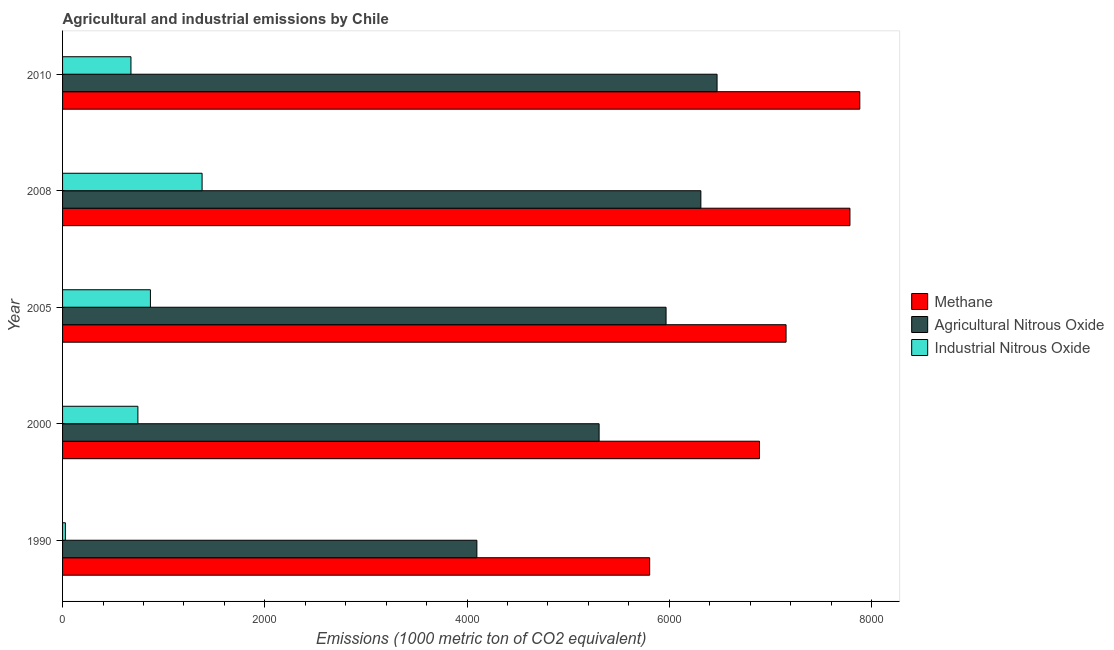What is the label of the 1st group of bars from the top?
Your response must be concise. 2010. What is the amount of methane emissions in 2005?
Your response must be concise. 7154.5. Across all years, what is the maximum amount of methane emissions?
Give a very brief answer. 7883.7. Across all years, what is the minimum amount of agricultural nitrous oxide emissions?
Your response must be concise. 4097. In which year was the amount of methane emissions maximum?
Your answer should be very brief. 2010. In which year was the amount of agricultural nitrous oxide emissions minimum?
Keep it short and to the point. 1990. What is the total amount of agricultural nitrous oxide emissions in the graph?
Offer a very short reply. 2.82e+04. What is the difference between the amount of industrial nitrous oxide emissions in 2005 and that in 2010?
Give a very brief answer. 192.5. What is the difference between the amount of agricultural nitrous oxide emissions in 1990 and the amount of methane emissions in 2005?
Give a very brief answer. -3057.5. What is the average amount of industrial nitrous oxide emissions per year?
Your answer should be compact. 739.52. In the year 2005, what is the difference between the amount of agricultural nitrous oxide emissions and amount of industrial nitrous oxide emissions?
Offer a very short reply. 5099. In how many years, is the amount of industrial nitrous oxide emissions greater than 1600 metric ton?
Your answer should be very brief. 0. What is the ratio of the amount of agricultural nitrous oxide emissions in 2000 to that in 2008?
Offer a very short reply. 0.84. Is the amount of methane emissions in 1990 less than that in 2010?
Keep it short and to the point. Yes. Is the difference between the amount of industrial nitrous oxide emissions in 2000 and 2005 greater than the difference between the amount of methane emissions in 2000 and 2005?
Your answer should be compact. Yes. What is the difference between the highest and the second highest amount of industrial nitrous oxide emissions?
Provide a short and direct response. 510.9. What is the difference between the highest and the lowest amount of industrial nitrous oxide emissions?
Ensure brevity in your answer.  1351.8. Is the sum of the amount of industrial nitrous oxide emissions in 2005 and 2010 greater than the maximum amount of methane emissions across all years?
Your answer should be compact. No. What does the 3rd bar from the top in 1990 represents?
Offer a very short reply. Methane. What does the 1st bar from the bottom in 2000 represents?
Provide a short and direct response. Methane. Is it the case that in every year, the sum of the amount of methane emissions and amount of agricultural nitrous oxide emissions is greater than the amount of industrial nitrous oxide emissions?
Your answer should be very brief. Yes. How many bars are there?
Make the answer very short. 15. How many years are there in the graph?
Ensure brevity in your answer.  5. Does the graph contain grids?
Keep it short and to the point. No. Where does the legend appear in the graph?
Keep it short and to the point. Center right. How many legend labels are there?
Your response must be concise. 3. What is the title of the graph?
Keep it short and to the point. Agricultural and industrial emissions by Chile. Does "Agriculture" appear as one of the legend labels in the graph?
Make the answer very short. No. What is the label or title of the X-axis?
Offer a very short reply. Emissions (1000 metric ton of CO2 equivalent). What is the Emissions (1000 metric ton of CO2 equivalent) in Methane in 1990?
Offer a very short reply. 5805.8. What is the Emissions (1000 metric ton of CO2 equivalent) in Agricultural Nitrous Oxide in 1990?
Your response must be concise. 4097. What is the Emissions (1000 metric ton of CO2 equivalent) of Industrial Nitrous Oxide in 1990?
Give a very brief answer. 27.9. What is the Emissions (1000 metric ton of CO2 equivalent) in Methane in 2000?
Ensure brevity in your answer.  6891.6. What is the Emissions (1000 metric ton of CO2 equivalent) of Agricultural Nitrous Oxide in 2000?
Your response must be concise. 5305.7. What is the Emissions (1000 metric ton of CO2 equivalent) of Industrial Nitrous Oxide in 2000?
Provide a succinct answer. 744.9. What is the Emissions (1000 metric ton of CO2 equivalent) of Methane in 2005?
Offer a very short reply. 7154.5. What is the Emissions (1000 metric ton of CO2 equivalent) of Agricultural Nitrous Oxide in 2005?
Provide a succinct answer. 5967.8. What is the Emissions (1000 metric ton of CO2 equivalent) in Industrial Nitrous Oxide in 2005?
Give a very brief answer. 868.8. What is the Emissions (1000 metric ton of CO2 equivalent) in Methane in 2008?
Offer a very short reply. 7786.1. What is the Emissions (1000 metric ton of CO2 equivalent) of Agricultural Nitrous Oxide in 2008?
Your answer should be compact. 6312. What is the Emissions (1000 metric ton of CO2 equivalent) in Industrial Nitrous Oxide in 2008?
Provide a succinct answer. 1379.7. What is the Emissions (1000 metric ton of CO2 equivalent) of Methane in 2010?
Your response must be concise. 7883.7. What is the Emissions (1000 metric ton of CO2 equivalent) in Agricultural Nitrous Oxide in 2010?
Offer a terse response. 6472.2. What is the Emissions (1000 metric ton of CO2 equivalent) in Industrial Nitrous Oxide in 2010?
Your answer should be very brief. 676.3. Across all years, what is the maximum Emissions (1000 metric ton of CO2 equivalent) in Methane?
Your answer should be compact. 7883.7. Across all years, what is the maximum Emissions (1000 metric ton of CO2 equivalent) in Agricultural Nitrous Oxide?
Your answer should be very brief. 6472.2. Across all years, what is the maximum Emissions (1000 metric ton of CO2 equivalent) in Industrial Nitrous Oxide?
Your answer should be compact. 1379.7. Across all years, what is the minimum Emissions (1000 metric ton of CO2 equivalent) of Methane?
Make the answer very short. 5805.8. Across all years, what is the minimum Emissions (1000 metric ton of CO2 equivalent) of Agricultural Nitrous Oxide?
Ensure brevity in your answer.  4097. Across all years, what is the minimum Emissions (1000 metric ton of CO2 equivalent) of Industrial Nitrous Oxide?
Offer a very short reply. 27.9. What is the total Emissions (1000 metric ton of CO2 equivalent) in Methane in the graph?
Your answer should be very brief. 3.55e+04. What is the total Emissions (1000 metric ton of CO2 equivalent) in Agricultural Nitrous Oxide in the graph?
Provide a succinct answer. 2.82e+04. What is the total Emissions (1000 metric ton of CO2 equivalent) of Industrial Nitrous Oxide in the graph?
Keep it short and to the point. 3697.6. What is the difference between the Emissions (1000 metric ton of CO2 equivalent) of Methane in 1990 and that in 2000?
Offer a terse response. -1085.8. What is the difference between the Emissions (1000 metric ton of CO2 equivalent) of Agricultural Nitrous Oxide in 1990 and that in 2000?
Offer a terse response. -1208.7. What is the difference between the Emissions (1000 metric ton of CO2 equivalent) of Industrial Nitrous Oxide in 1990 and that in 2000?
Keep it short and to the point. -717. What is the difference between the Emissions (1000 metric ton of CO2 equivalent) in Methane in 1990 and that in 2005?
Provide a short and direct response. -1348.7. What is the difference between the Emissions (1000 metric ton of CO2 equivalent) of Agricultural Nitrous Oxide in 1990 and that in 2005?
Your answer should be compact. -1870.8. What is the difference between the Emissions (1000 metric ton of CO2 equivalent) of Industrial Nitrous Oxide in 1990 and that in 2005?
Provide a succinct answer. -840.9. What is the difference between the Emissions (1000 metric ton of CO2 equivalent) of Methane in 1990 and that in 2008?
Offer a very short reply. -1980.3. What is the difference between the Emissions (1000 metric ton of CO2 equivalent) in Agricultural Nitrous Oxide in 1990 and that in 2008?
Keep it short and to the point. -2215. What is the difference between the Emissions (1000 metric ton of CO2 equivalent) in Industrial Nitrous Oxide in 1990 and that in 2008?
Your answer should be very brief. -1351.8. What is the difference between the Emissions (1000 metric ton of CO2 equivalent) of Methane in 1990 and that in 2010?
Give a very brief answer. -2077.9. What is the difference between the Emissions (1000 metric ton of CO2 equivalent) in Agricultural Nitrous Oxide in 1990 and that in 2010?
Your answer should be compact. -2375.2. What is the difference between the Emissions (1000 metric ton of CO2 equivalent) in Industrial Nitrous Oxide in 1990 and that in 2010?
Your answer should be very brief. -648.4. What is the difference between the Emissions (1000 metric ton of CO2 equivalent) of Methane in 2000 and that in 2005?
Your answer should be compact. -262.9. What is the difference between the Emissions (1000 metric ton of CO2 equivalent) of Agricultural Nitrous Oxide in 2000 and that in 2005?
Offer a terse response. -662.1. What is the difference between the Emissions (1000 metric ton of CO2 equivalent) of Industrial Nitrous Oxide in 2000 and that in 2005?
Your response must be concise. -123.9. What is the difference between the Emissions (1000 metric ton of CO2 equivalent) in Methane in 2000 and that in 2008?
Provide a succinct answer. -894.5. What is the difference between the Emissions (1000 metric ton of CO2 equivalent) in Agricultural Nitrous Oxide in 2000 and that in 2008?
Make the answer very short. -1006.3. What is the difference between the Emissions (1000 metric ton of CO2 equivalent) in Industrial Nitrous Oxide in 2000 and that in 2008?
Ensure brevity in your answer.  -634.8. What is the difference between the Emissions (1000 metric ton of CO2 equivalent) of Methane in 2000 and that in 2010?
Offer a terse response. -992.1. What is the difference between the Emissions (1000 metric ton of CO2 equivalent) of Agricultural Nitrous Oxide in 2000 and that in 2010?
Provide a succinct answer. -1166.5. What is the difference between the Emissions (1000 metric ton of CO2 equivalent) in Industrial Nitrous Oxide in 2000 and that in 2010?
Your answer should be compact. 68.6. What is the difference between the Emissions (1000 metric ton of CO2 equivalent) in Methane in 2005 and that in 2008?
Give a very brief answer. -631.6. What is the difference between the Emissions (1000 metric ton of CO2 equivalent) in Agricultural Nitrous Oxide in 2005 and that in 2008?
Keep it short and to the point. -344.2. What is the difference between the Emissions (1000 metric ton of CO2 equivalent) of Industrial Nitrous Oxide in 2005 and that in 2008?
Your answer should be very brief. -510.9. What is the difference between the Emissions (1000 metric ton of CO2 equivalent) of Methane in 2005 and that in 2010?
Offer a very short reply. -729.2. What is the difference between the Emissions (1000 metric ton of CO2 equivalent) of Agricultural Nitrous Oxide in 2005 and that in 2010?
Make the answer very short. -504.4. What is the difference between the Emissions (1000 metric ton of CO2 equivalent) in Industrial Nitrous Oxide in 2005 and that in 2010?
Offer a very short reply. 192.5. What is the difference between the Emissions (1000 metric ton of CO2 equivalent) in Methane in 2008 and that in 2010?
Your response must be concise. -97.6. What is the difference between the Emissions (1000 metric ton of CO2 equivalent) in Agricultural Nitrous Oxide in 2008 and that in 2010?
Your answer should be compact. -160.2. What is the difference between the Emissions (1000 metric ton of CO2 equivalent) of Industrial Nitrous Oxide in 2008 and that in 2010?
Keep it short and to the point. 703.4. What is the difference between the Emissions (1000 metric ton of CO2 equivalent) in Methane in 1990 and the Emissions (1000 metric ton of CO2 equivalent) in Agricultural Nitrous Oxide in 2000?
Provide a short and direct response. 500.1. What is the difference between the Emissions (1000 metric ton of CO2 equivalent) in Methane in 1990 and the Emissions (1000 metric ton of CO2 equivalent) in Industrial Nitrous Oxide in 2000?
Give a very brief answer. 5060.9. What is the difference between the Emissions (1000 metric ton of CO2 equivalent) of Agricultural Nitrous Oxide in 1990 and the Emissions (1000 metric ton of CO2 equivalent) of Industrial Nitrous Oxide in 2000?
Your answer should be very brief. 3352.1. What is the difference between the Emissions (1000 metric ton of CO2 equivalent) of Methane in 1990 and the Emissions (1000 metric ton of CO2 equivalent) of Agricultural Nitrous Oxide in 2005?
Provide a short and direct response. -162. What is the difference between the Emissions (1000 metric ton of CO2 equivalent) of Methane in 1990 and the Emissions (1000 metric ton of CO2 equivalent) of Industrial Nitrous Oxide in 2005?
Make the answer very short. 4937. What is the difference between the Emissions (1000 metric ton of CO2 equivalent) in Agricultural Nitrous Oxide in 1990 and the Emissions (1000 metric ton of CO2 equivalent) in Industrial Nitrous Oxide in 2005?
Ensure brevity in your answer.  3228.2. What is the difference between the Emissions (1000 metric ton of CO2 equivalent) of Methane in 1990 and the Emissions (1000 metric ton of CO2 equivalent) of Agricultural Nitrous Oxide in 2008?
Make the answer very short. -506.2. What is the difference between the Emissions (1000 metric ton of CO2 equivalent) of Methane in 1990 and the Emissions (1000 metric ton of CO2 equivalent) of Industrial Nitrous Oxide in 2008?
Keep it short and to the point. 4426.1. What is the difference between the Emissions (1000 metric ton of CO2 equivalent) in Agricultural Nitrous Oxide in 1990 and the Emissions (1000 metric ton of CO2 equivalent) in Industrial Nitrous Oxide in 2008?
Provide a succinct answer. 2717.3. What is the difference between the Emissions (1000 metric ton of CO2 equivalent) of Methane in 1990 and the Emissions (1000 metric ton of CO2 equivalent) of Agricultural Nitrous Oxide in 2010?
Provide a succinct answer. -666.4. What is the difference between the Emissions (1000 metric ton of CO2 equivalent) in Methane in 1990 and the Emissions (1000 metric ton of CO2 equivalent) in Industrial Nitrous Oxide in 2010?
Your answer should be compact. 5129.5. What is the difference between the Emissions (1000 metric ton of CO2 equivalent) in Agricultural Nitrous Oxide in 1990 and the Emissions (1000 metric ton of CO2 equivalent) in Industrial Nitrous Oxide in 2010?
Keep it short and to the point. 3420.7. What is the difference between the Emissions (1000 metric ton of CO2 equivalent) of Methane in 2000 and the Emissions (1000 metric ton of CO2 equivalent) of Agricultural Nitrous Oxide in 2005?
Keep it short and to the point. 923.8. What is the difference between the Emissions (1000 metric ton of CO2 equivalent) of Methane in 2000 and the Emissions (1000 metric ton of CO2 equivalent) of Industrial Nitrous Oxide in 2005?
Keep it short and to the point. 6022.8. What is the difference between the Emissions (1000 metric ton of CO2 equivalent) in Agricultural Nitrous Oxide in 2000 and the Emissions (1000 metric ton of CO2 equivalent) in Industrial Nitrous Oxide in 2005?
Provide a succinct answer. 4436.9. What is the difference between the Emissions (1000 metric ton of CO2 equivalent) in Methane in 2000 and the Emissions (1000 metric ton of CO2 equivalent) in Agricultural Nitrous Oxide in 2008?
Provide a succinct answer. 579.6. What is the difference between the Emissions (1000 metric ton of CO2 equivalent) of Methane in 2000 and the Emissions (1000 metric ton of CO2 equivalent) of Industrial Nitrous Oxide in 2008?
Ensure brevity in your answer.  5511.9. What is the difference between the Emissions (1000 metric ton of CO2 equivalent) in Agricultural Nitrous Oxide in 2000 and the Emissions (1000 metric ton of CO2 equivalent) in Industrial Nitrous Oxide in 2008?
Provide a succinct answer. 3926. What is the difference between the Emissions (1000 metric ton of CO2 equivalent) in Methane in 2000 and the Emissions (1000 metric ton of CO2 equivalent) in Agricultural Nitrous Oxide in 2010?
Give a very brief answer. 419.4. What is the difference between the Emissions (1000 metric ton of CO2 equivalent) in Methane in 2000 and the Emissions (1000 metric ton of CO2 equivalent) in Industrial Nitrous Oxide in 2010?
Provide a succinct answer. 6215.3. What is the difference between the Emissions (1000 metric ton of CO2 equivalent) in Agricultural Nitrous Oxide in 2000 and the Emissions (1000 metric ton of CO2 equivalent) in Industrial Nitrous Oxide in 2010?
Keep it short and to the point. 4629.4. What is the difference between the Emissions (1000 metric ton of CO2 equivalent) of Methane in 2005 and the Emissions (1000 metric ton of CO2 equivalent) of Agricultural Nitrous Oxide in 2008?
Offer a terse response. 842.5. What is the difference between the Emissions (1000 metric ton of CO2 equivalent) of Methane in 2005 and the Emissions (1000 metric ton of CO2 equivalent) of Industrial Nitrous Oxide in 2008?
Your answer should be very brief. 5774.8. What is the difference between the Emissions (1000 metric ton of CO2 equivalent) in Agricultural Nitrous Oxide in 2005 and the Emissions (1000 metric ton of CO2 equivalent) in Industrial Nitrous Oxide in 2008?
Make the answer very short. 4588.1. What is the difference between the Emissions (1000 metric ton of CO2 equivalent) of Methane in 2005 and the Emissions (1000 metric ton of CO2 equivalent) of Agricultural Nitrous Oxide in 2010?
Keep it short and to the point. 682.3. What is the difference between the Emissions (1000 metric ton of CO2 equivalent) of Methane in 2005 and the Emissions (1000 metric ton of CO2 equivalent) of Industrial Nitrous Oxide in 2010?
Keep it short and to the point. 6478.2. What is the difference between the Emissions (1000 metric ton of CO2 equivalent) of Agricultural Nitrous Oxide in 2005 and the Emissions (1000 metric ton of CO2 equivalent) of Industrial Nitrous Oxide in 2010?
Provide a short and direct response. 5291.5. What is the difference between the Emissions (1000 metric ton of CO2 equivalent) of Methane in 2008 and the Emissions (1000 metric ton of CO2 equivalent) of Agricultural Nitrous Oxide in 2010?
Ensure brevity in your answer.  1313.9. What is the difference between the Emissions (1000 metric ton of CO2 equivalent) in Methane in 2008 and the Emissions (1000 metric ton of CO2 equivalent) in Industrial Nitrous Oxide in 2010?
Offer a terse response. 7109.8. What is the difference between the Emissions (1000 metric ton of CO2 equivalent) of Agricultural Nitrous Oxide in 2008 and the Emissions (1000 metric ton of CO2 equivalent) of Industrial Nitrous Oxide in 2010?
Give a very brief answer. 5635.7. What is the average Emissions (1000 metric ton of CO2 equivalent) in Methane per year?
Keep it short and to the point. 7104.34. What is the average Emissions (1000 metric ton of CO2 equivalent) of Agricultural Nitrous Oxide per year?
Offer a terse response. 5630.94. What is the average Emissions (1000 metric ton of CO2 equivalent) of Industrial Nitrous Oxide per year?
Give a very brief answer. 739.52. In the year 1990, what is the difference between the Emissions (1000 metric ton of CO2 equivalent) of Methane and Emissions (1000 metric ton of CO2 equivalent) of Agricultural Nitrous Oxide?
Your answer should be very brief. 1708.8. In the year 1990, what is the difference between the Emissions (1000 metric ton of CO2 equivalent) in Methane and Emissions (1000 metric ton of CO2 equivalent) in Industrial Nitrous Oxide?
Your answer should be compact. 5777.9. In the year 1990, what is the difference between the Emissions (1000 metric ton of CO2 equivalent) in Agricultural Nitrous Oxide and Emissions (1000 metric ton of CO2 equivalent) in Industrial Nitrous Oxide?
Offer a very short reply. 4069.1. In the year 2000, what is the difference between the Emissions (1000 metric ton of CO2 equivalent) in Methane and Emissions (1000 metric ton of CO2 equivalent) in Agricultural Nitrous Oxide?
Your response must be concise. 1585.9. In the year 2000, what is the difference between the Emissions (1000 metric ton of CO2 equivalent) of Methane and Emissions (1000 metric ton of CO2 equivalent) of Industrial Nitrous Oxide?
Offer a very short reply. 6146.7. In the year 2000, what is the difference between the Emissions (1000 metric ton of CO2 equivalent) of Agricultural Nitrous Oxide and Emissions (1000 metric ton of CO2 equivalent) of Industrial Nitrous Oxide?
Provide a succinct answer. 4560.8. In the year 2005, what is the difference between the Emissions (1000 metric ton of CO2 equivalent) in Methane and Emissions (1000 metric ton of CO2 equivalent) in Agricultural Nitrous Oxide?
Your answer should be compact. 1186.7. In the year 2005, what is the difference between the Emissions (1000 metric ton of CO2 equivalent) in Methane and Emissions (1000 metric ton of CO2 equivalent) in Industrial Nitrous Oxide?
Make the answer very short. 6285.7. In the year 2005, what is the difference between the Emissions (1000 metric ton of CO2 equivalent) in Agricultural Nitrous Oxide and Emissions (1000 metric ton of CO2 equivalent) in Industrial Nitrous Oxide?
Provide a succinct answer. 5099. In the year 2008, what is the difference between the Emissions (1000 metric ton of CO2 equivalent) of Methane and Emissions (1000 metric ton of CO2 equivalent) of Agricultural Nitrous Oxide?
Keep it short and to the point. 1474.1. In the year 2008, what is the difference between the Emissions (1000 metric ton of CO2 equivalent) in Methane and Emissions (1000 metric ton of CO2 equivalent) in Industrial Nitrous Oxide?
Offer a very short reply. 6406.4. In the year 2008, what is the difference between the Emissions (1000 metric ton of CO2 equivalent) in Agricultural Nitrous Oxide and Emissions (1000 metric ton of CO2 equivalent) in Industrial Nitrous Oxide?
Make the answer very short. 4932.3. In the year 2010, what is the difference between the Emissions (1000 metric ton of CO2 equivalent) in Methane and Emissions (1000 metric ton of CO2 equivalent) in Agricultural Nitrous Oxide?
Provide a succinct answer. 1411.5. In the year 2010, what is the difference between the Emissions (1000 metric ton of CO2 equivalent) in Methane and Emissions (1000 metric ton of CO2 equivalent) in Industrial Nitrous Oxide?
Your answer should be compact. 7207.4. In the year 2010, what is the difference between the Emissions (1000 metric ton of CO2 equivalent) in Agricultural Nitrous Oxide and Emissions (1000 metric ton of CO2 equivalent) in Industrial Nitrous Oxide?
Keep it short and to the point. 5795.9. What is the ratio of the Emissions (1000 metric ton of CO2 equivalent) of Methane in 1990 to that in 2000?
Provide a succinct answer. 0.84. What is the ratio of the Emissions (1000 metric ton of CO2 equivalent) in Agricultural Nitrous Oxide in 1990 to that in 2000?
Your answer should be very brief. 0.77. What is the ratio of the Emissions (1000 metric ton of CO2 equivalent) in Industrial Nitrous Oxide in 1990 to that in 2000?
Make the answer very short. 0.04. What is the ratio of the Emissions (1000 metric ton of CO2 equivalent) of Methane in 1990 to that in 2005?
Your response must be concise. 0.81. What is the ratio of the Emissions (1000 metric ton of CO2 equivalent) in Agricultural Nitrous Oxide in 1990 to that in 2005?
Offer a terse response. 0.69. What is the ratio of the Emissions (1000 metric ton of CO2 equivalent) of Industrial Nitrous Oxide in 1990 to that in 2005?
Make the answer very short. 0.03. What is the ratio of the Emissions (1000 metric ton of CO2 equivalent) of Methane in 1990 to that in 2008?
Give a very brief answer. 0.75. What is the ratio of the Emissions (1000 metric ton of CO2 equivalent) of Agricultural Nitrous Oxide in 1990 to that in 2008?
Give a very brief answer. 0.65. What is the ratio of the Emissions (1000 metric ton of CO2 equivalent) in Industrial Nitrous Oxide in 1990 to that in 2008?
Offer a terse response. 0.02. What is the ratio of the Emissions (1000 metric ton of CO2 equivalent) of Methane in 1990 to that in 2010?
Your answer should be compact. 0.74. What is the ratio of the Emissions (1000 metric ton of CO2 equivalent) of Agricultural Nitrous Oxide in 1990 to that in 2010?
Offer a very short reply. 0.63. What is the ratio of the Emissions (1000 metric ton of CO2 equivalent) in Industrial Nitrous Oxide in 1990 to that in 2010?
Your answer should be very brief. 0.04. What is the ratio of the Emissions (1000 metric ton of CO2 equivalent) of Methane in 2000 to that in 2005?
Your answer should be very brief. 0.96. What is the ratio of the Emissions (1000 metric ton of CO2 equivalent) in Agricultural Nitrous Oxide in 2000 to that in 2005?
Ensure brevity in your answer.  0.89. What is the ratio of the Emissions (1000 metric ton of CO2 equivalent) of Industrial Nitrous Oxide in 2000 to that in 2005?
Offer a terse response. 0.86. What is the ratio of the Emissions (1000 metric ton of CO2 equivalent) in Methane in 2000 to that in 2008?
Your answer should be very brief. 0.89. What is the ratio of the Emissions (1000 metric ton of CO2 equivalent) of Agricultural Nitrous Oxide in 2000 to that in 2008?
Offer a terse response. 0.84. What is the ratio of the Emissions (1000 metric ton of CO2 equivalent) of Industrial Nitrous Oxide in 2000 to that in 2008?
Keep it short and to the point. 0.54. What is the ratio of the Emissions (1000 metric ton of CO2 equivalent) in Methane in 2000 to that in 2010?
Give a very brief answer. 0.87. What is the ratio of the Emissions (1000 metric ton of CO2 equivalent) in Agricultural Nitrous Oxide in 2000 to that in 2010?
Ensure brevity in your answer.  0.82. What is the ratio of the Emissions (1000 metric ton of CO2 equivalent) in Industrial Nitrous Oxide in 2000 to that in 2010?
Ensure brevity in your answer.  1.1. What is the ratio of the Emissions (1000 metric ton of CO2 equivalent) in Methane in 2005 to that in 2008?
Your response must be concise. 0.92. What is the ratio of the Emissions (1000 metric ton of CO2 equivalent) in Agricultural Nitrous Oxide in 2005 to that in 2008?
Provide a short and direct response. 0.95. What is the ratio of the Emissions (1000 metric ton of CO2 equivalent) of Industrial Nitrous Oxide in 2005 to that in 2008?
Ensure brevity in your answer.  0.63. What is the ratio of the Emissions (1000 metric ton of CO2 equivalent) in Methane in 2005 to that in 2010?
Your answer should be very brief. 0.91. What is the ratio of the Emissions (1000 metric ton of CO2 equivalent) of Agricultural Nitrous Oxide in 2005 to that in 2010?
Your answer should be very brief. 0.92. What is the ratio of the Emissions (1000 metric ton of CO2 equivalent) in Industrial Nitrous Oxide in 2005 to that in 2010?
Offer a terse response. 1.28. What is the ratio of the Emissions (1000 metric ton of CO2 equivalent) of Methane in 2008 to that in 2010?
Your response must be concise. 0.99. What is the ratio of the Emissions (1000 metric ton of CO2 equivalent) of Agricultural Nitrous Oxide in 2008 to that in 2010?
Offer a very short reply. 0.98. What is the ratio of the Emissions (1000 metric ton of CO2 equivalent) in Industrial Nitrous Oxide in 2008 to that in 2010?
Keep it short and to the point. 2.04. What is the difference between the highest and the second highest Emissions (1000 metric ton of CO2 equivalent) of Methane?
Make the answer very short. 97.6. What is the difference between the highest and the second highest Emissions (1000 metric ton of CO2 equivalent) in Agricultural Nitrous Oxide?
Offer a terse response. 160.2. What is the difference between the highest and the second highest Emissions (1000 metric ton of CO2 equivalent) of Industrial Nitrous Oxide?
Your response must be concise. 510.9. What is the difference between the highest and the lowest Emissions (1000 metric ton of CO2 equivalent) in Methane?
Your answer should be compact. 2077.9. What is the difference between the highest and the lowest Emissions (1000 metric ton of CO2 equivalent) in Agricultural Nitrous Oxide?
Offer a very short reply. 2375.2. What is the difference between the highest and the lowest Emissions (1000 metric ton of CO2 equivalent) in Industrial Nitrous Oxide?
Offer a very short reply. 1351.8. 